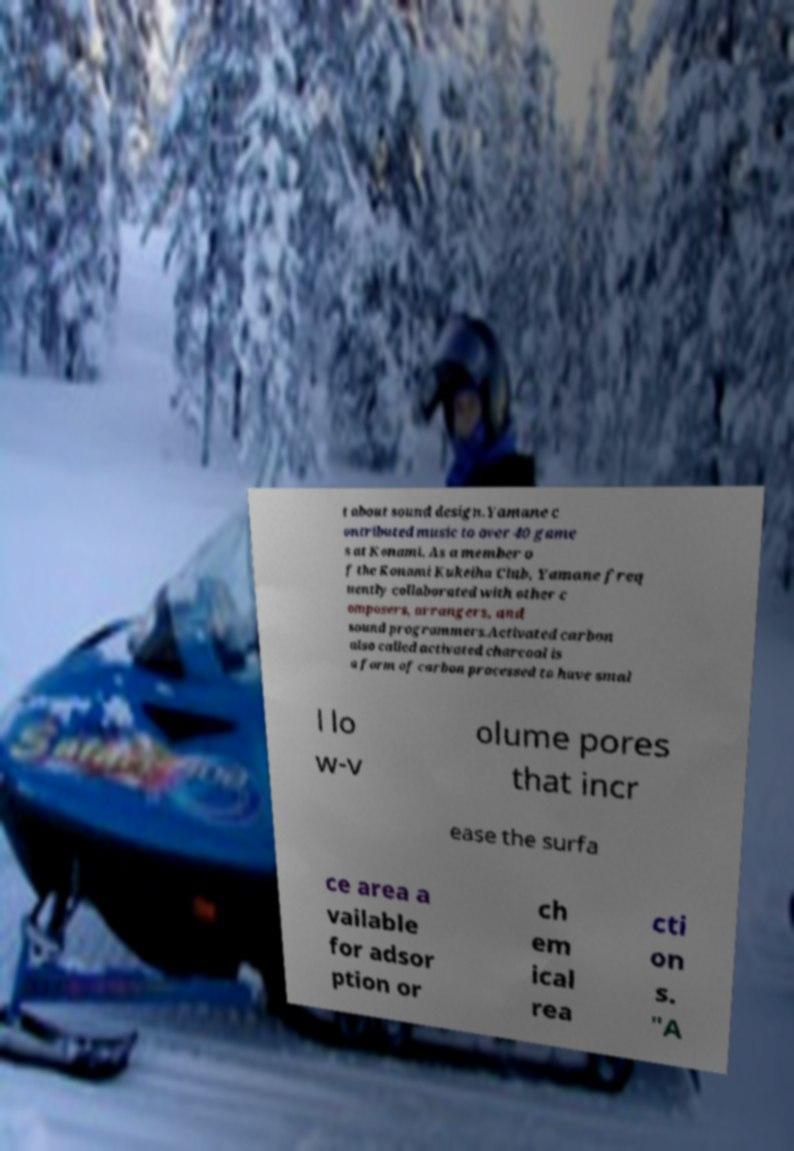For documentation purposes, I need the text within this image transcribed. Could you provide that? t about sound design.Yamane c ontributed music to over 40 game s at Konami. As a member o f the Konami Kukeiha Club, Yamane freq uently collaborated with other c omposers, arrangers, and sound programmers.Activated carbon also called activated charcoal is a form of carbon processed to have smal l lo w-v olume pores that incr ease the surfa ce area a vailable for adsor ption or ch em ical rea cti on s. "A 